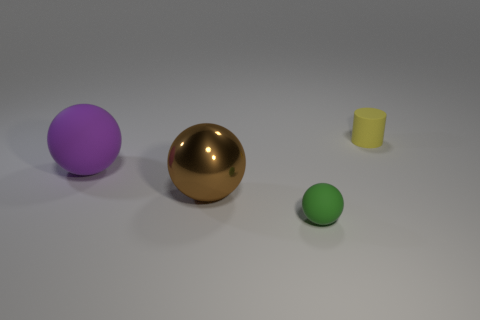If these objects were part of a physics simulation, what could you deduce about their potential interactions? Assuming they are placed on a flat surface with no initial forces applied, they'd likely remain stationary. However, if a force were to be applied, the objects might roll or slide depending on their shapes, with the sphere shapes rolling and the cylinder sliding if tipped over. 